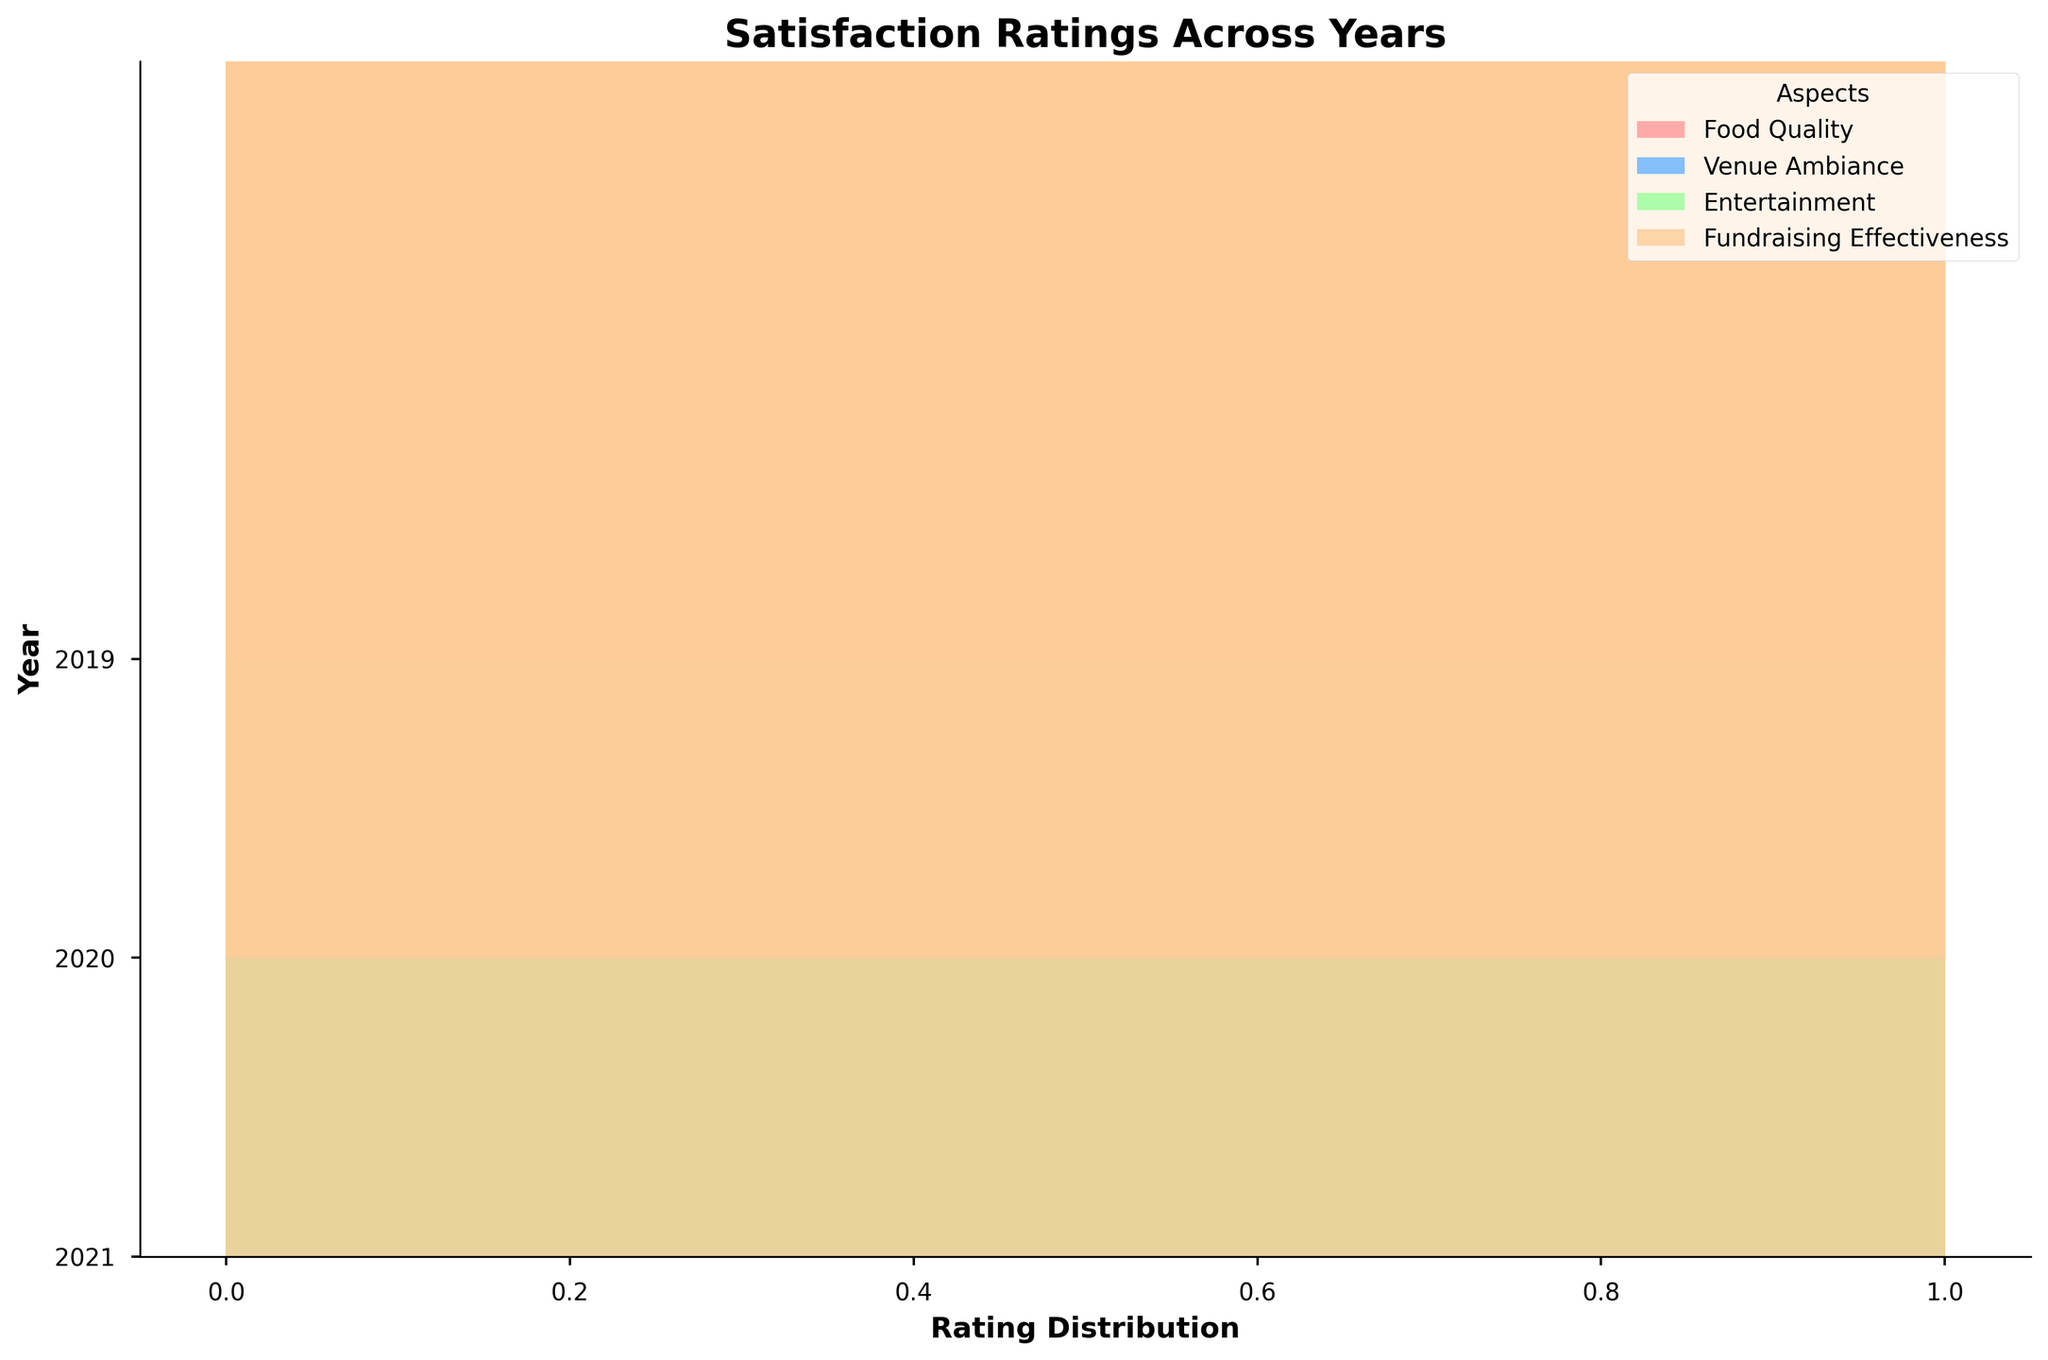What is the title of the figure? The title of the figure is usually placed at the top of the chart and summarizes what the chart represents. In this plot, the title is written in bold at the top.
Answer: Satisfaction Ratings Across Years What are the years represented on the y-axis? The y-axis labels indicate the years covered by the data, This is typically shown on the left side of the chart in the figure.
Answer: 2019, 2020, 2021 What colors represent different aspects in the figure? The colors corresponding to each aspect are illustrated in the legend. Each color on the plot indicates a different aspect under consideration.
Answer: Red (Food Quality), Blue (Venue Ambiance), Green (Entertainment), Orange (Fundraising Effectiveness) Which year shows the highest overall ratings? To determine the overall highest ratings for a particular year, observe the density of ratings towards the right (higher rating scale) for that year's ridgeline.
Answer: 2021 Which aspect has the most consistent high ratings in 2021? Look for the aspect whose ridgeline for the year 2021 is most skewed towards higher ratings consistently across the distribution.
Answer: Entertainment How does the distribution of ratings for Food Quality in 2020 compare to 2019? Compare the ridgelines of Food Quality for the years 2020 and 2019 visually, focusing on how the distributions align or differ along the rating axis.
Answer: The distribution in 2020 is centered slightly higher compared to 2019 Which aspect showed the most improvement in ratings from 2019 to 2021? Compare the ridgelines of all aspects between 2019 and 2021. Observe which aspect's distribution shifted most towards higher ratings over the years.
Answer: Fundraising Effectiveness Are there any aspects with notable dips in ratings in 2020 compared to 2019 and 2021? Observe the ridgelines for each aspect in 2020 and compare to the surrounding years to identify if any aspect has a noticeable shift towards lower ratings.
Answer: Venue Ambiance has a lower shift in 2020 compared to 2019 and 2021 What is the y-axis label in the figure? The y-axis label provides context for the data being plotted along the y-axis. It is typically located next to the y-axis.
Answer: Year Which aspect appears to have the highest range of satisfaction ratings in 2019? Examine the ridgelines for each aspect in 2019 and determine which aspect covers the widest range on the rating axis.
Answer: Entertainment 